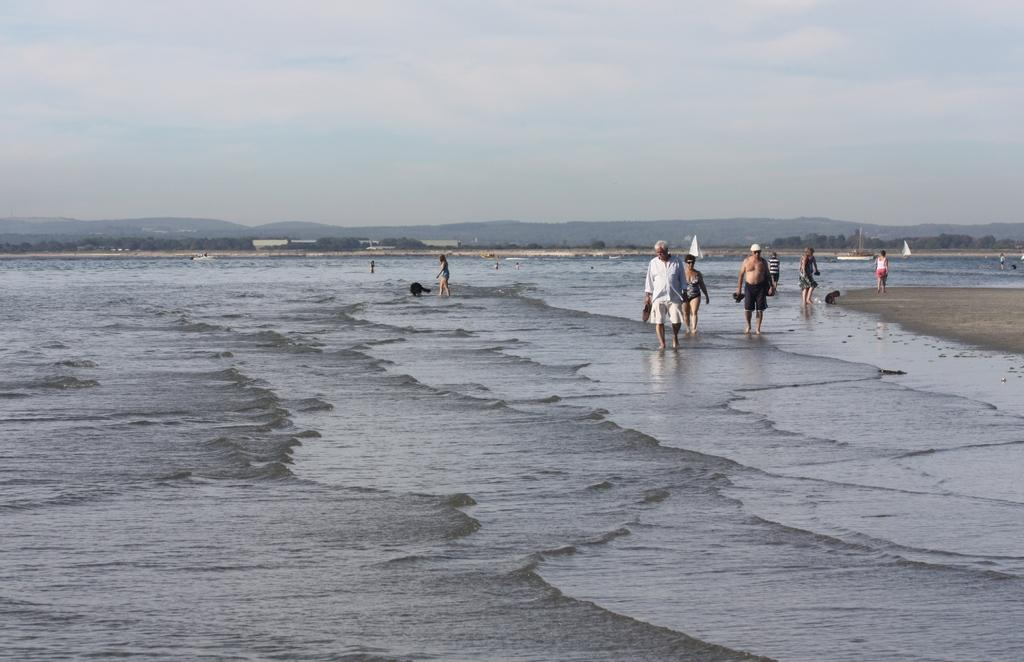What is the primary element visible in the image? There is water in the image. Who or what can be seen in the image? There are people in the image. What type of natural environment is visible in the background? There are trees in the background of the image. What is visible at the top of the image? The sky is visible at the top of the image. What type of mint can be seen growing on the page in the image? There is no mint or page present in the image. 